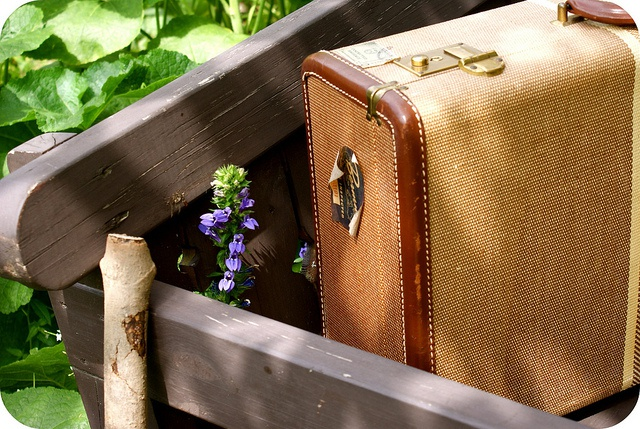Describe the objects in this image and their specific colors. I can see suitcase in white, maroon, brown, tan, and ivory tones and bench in white, black, darkgray, and maroon tones in this image. 